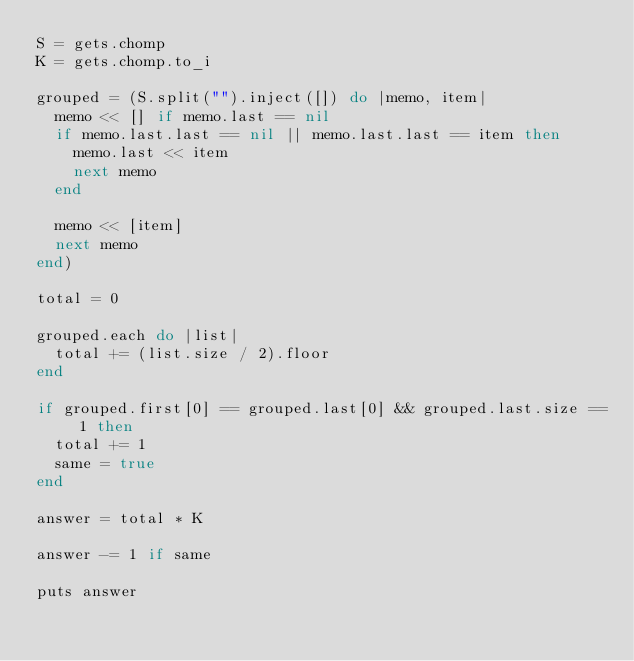<code> <loc_0><loc_0><loc_500><loc_500><_Ruby_>S = gets.chomp
K = gets.chomp.to_i

grouped = (S.split("").inject([]) do |memo, item|
  memo << [] if memo.last == nil
  if memo.last.last == nil || memo.last.last == item then
    memo.last << item
    next memo
  end

  memo << [item]
  next memo
end)

total = 0

grouped.each do |list|
  total += (list.size / 2).floor
end

if grouped.first[0] == grouped.last[0] && grouped.last.size == 1 then
  total += 1
  same = true
end

answer = total * K

answer -= 1 if same

puts answer</code> 